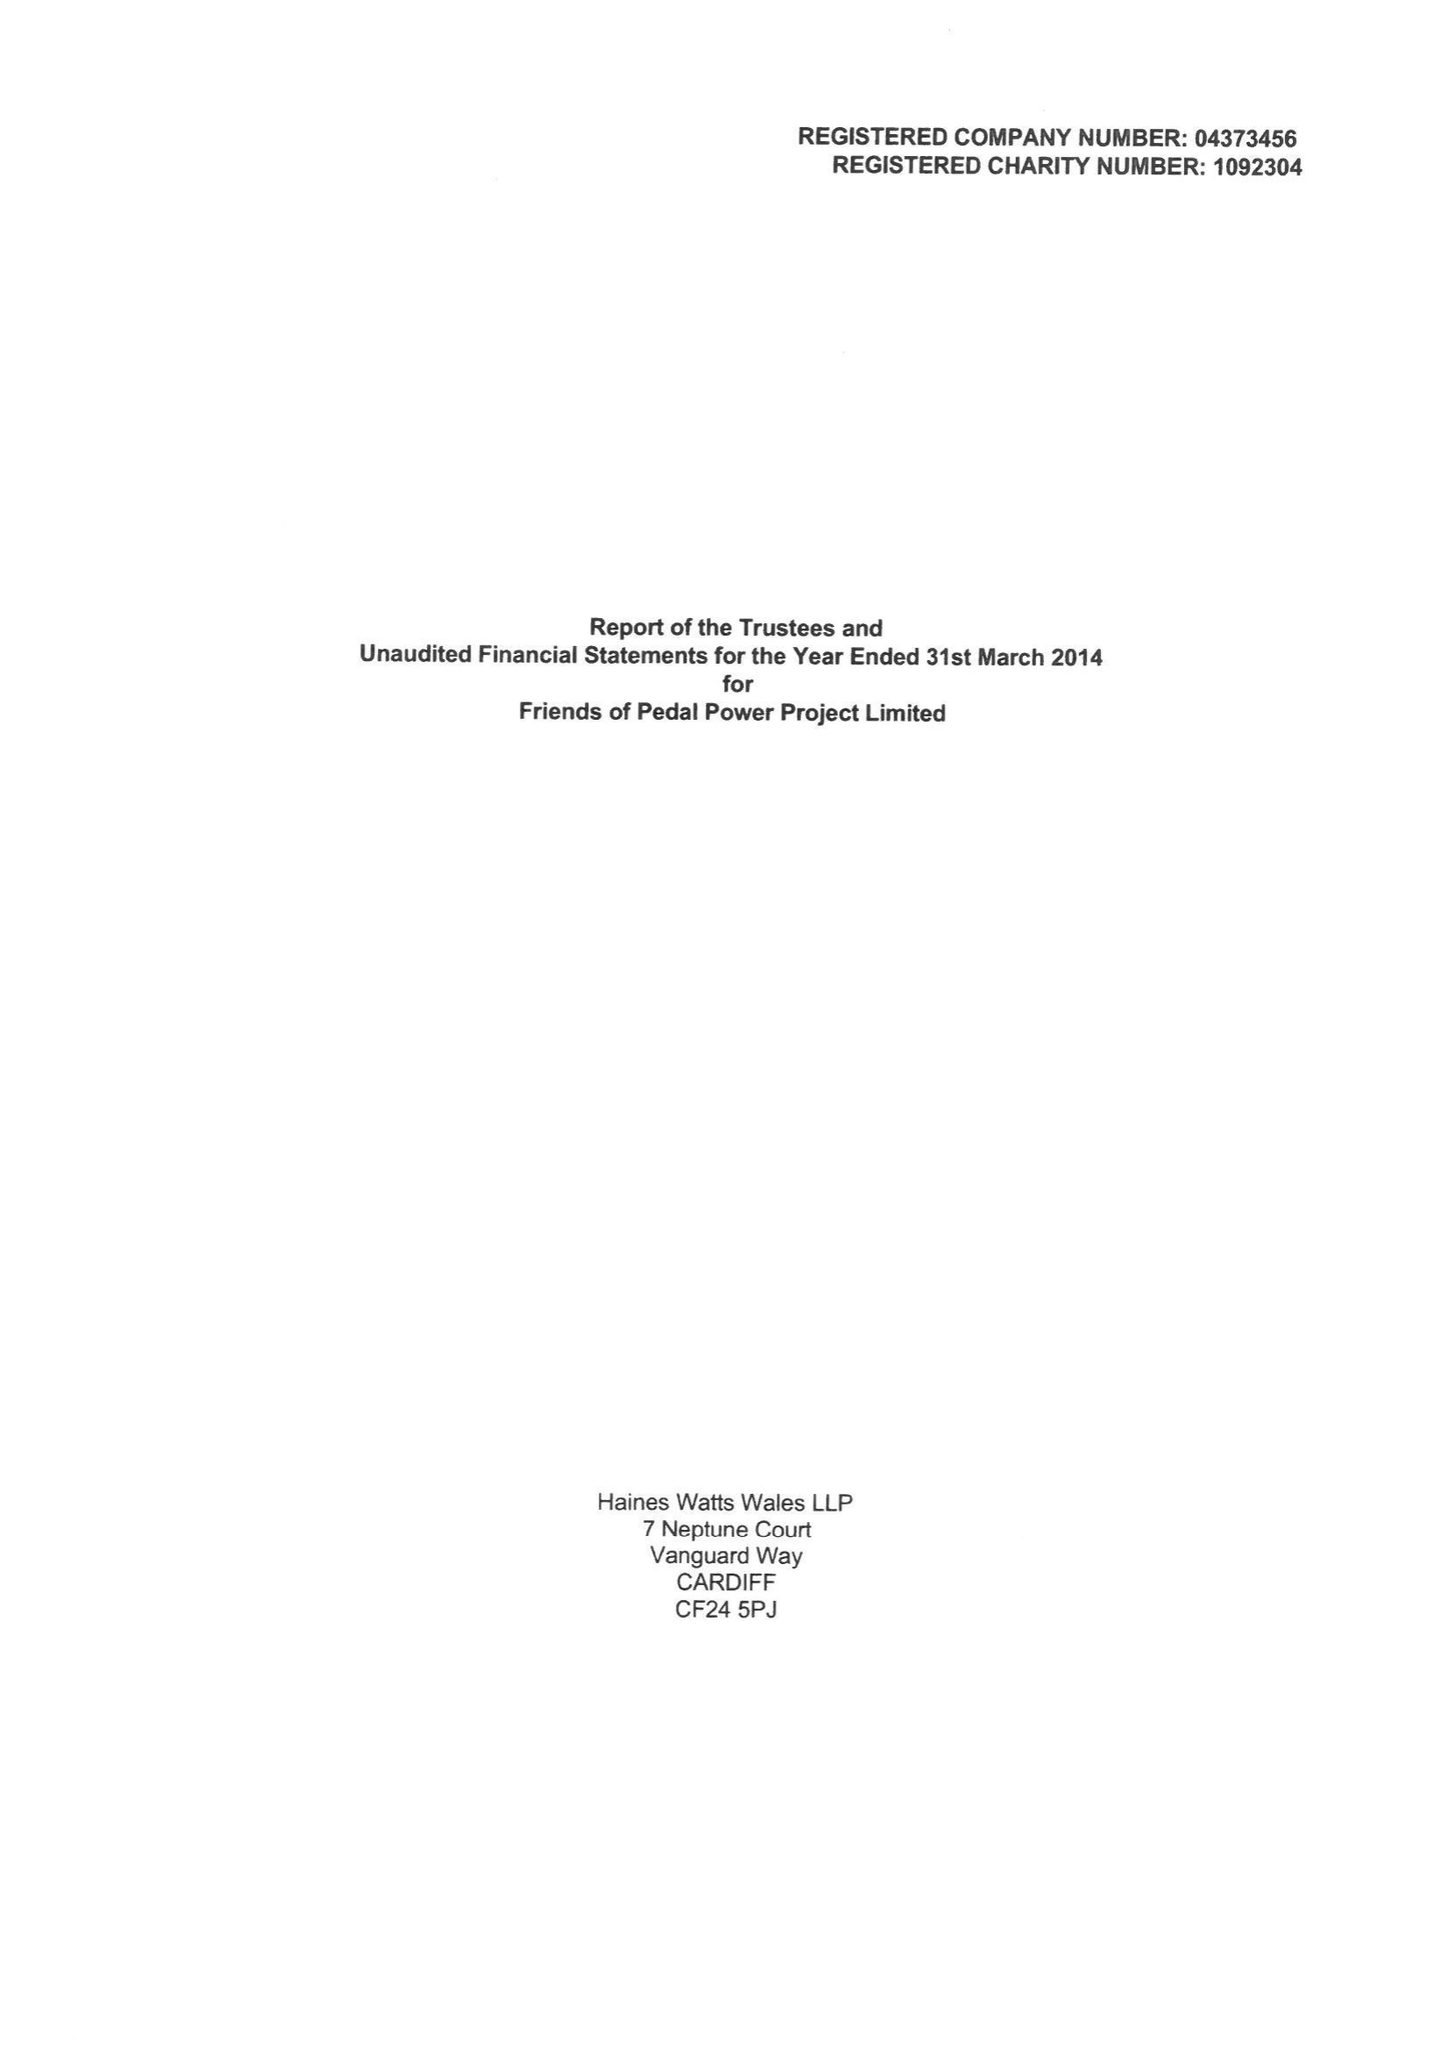What is the value for the address__postcode?
Answer the question using a single word or phrase. CF24 1PL 